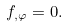<formula> <loc_0><loc_0><loc_500><loc_500>f _ { , \varphi } = 0 .</formula> 